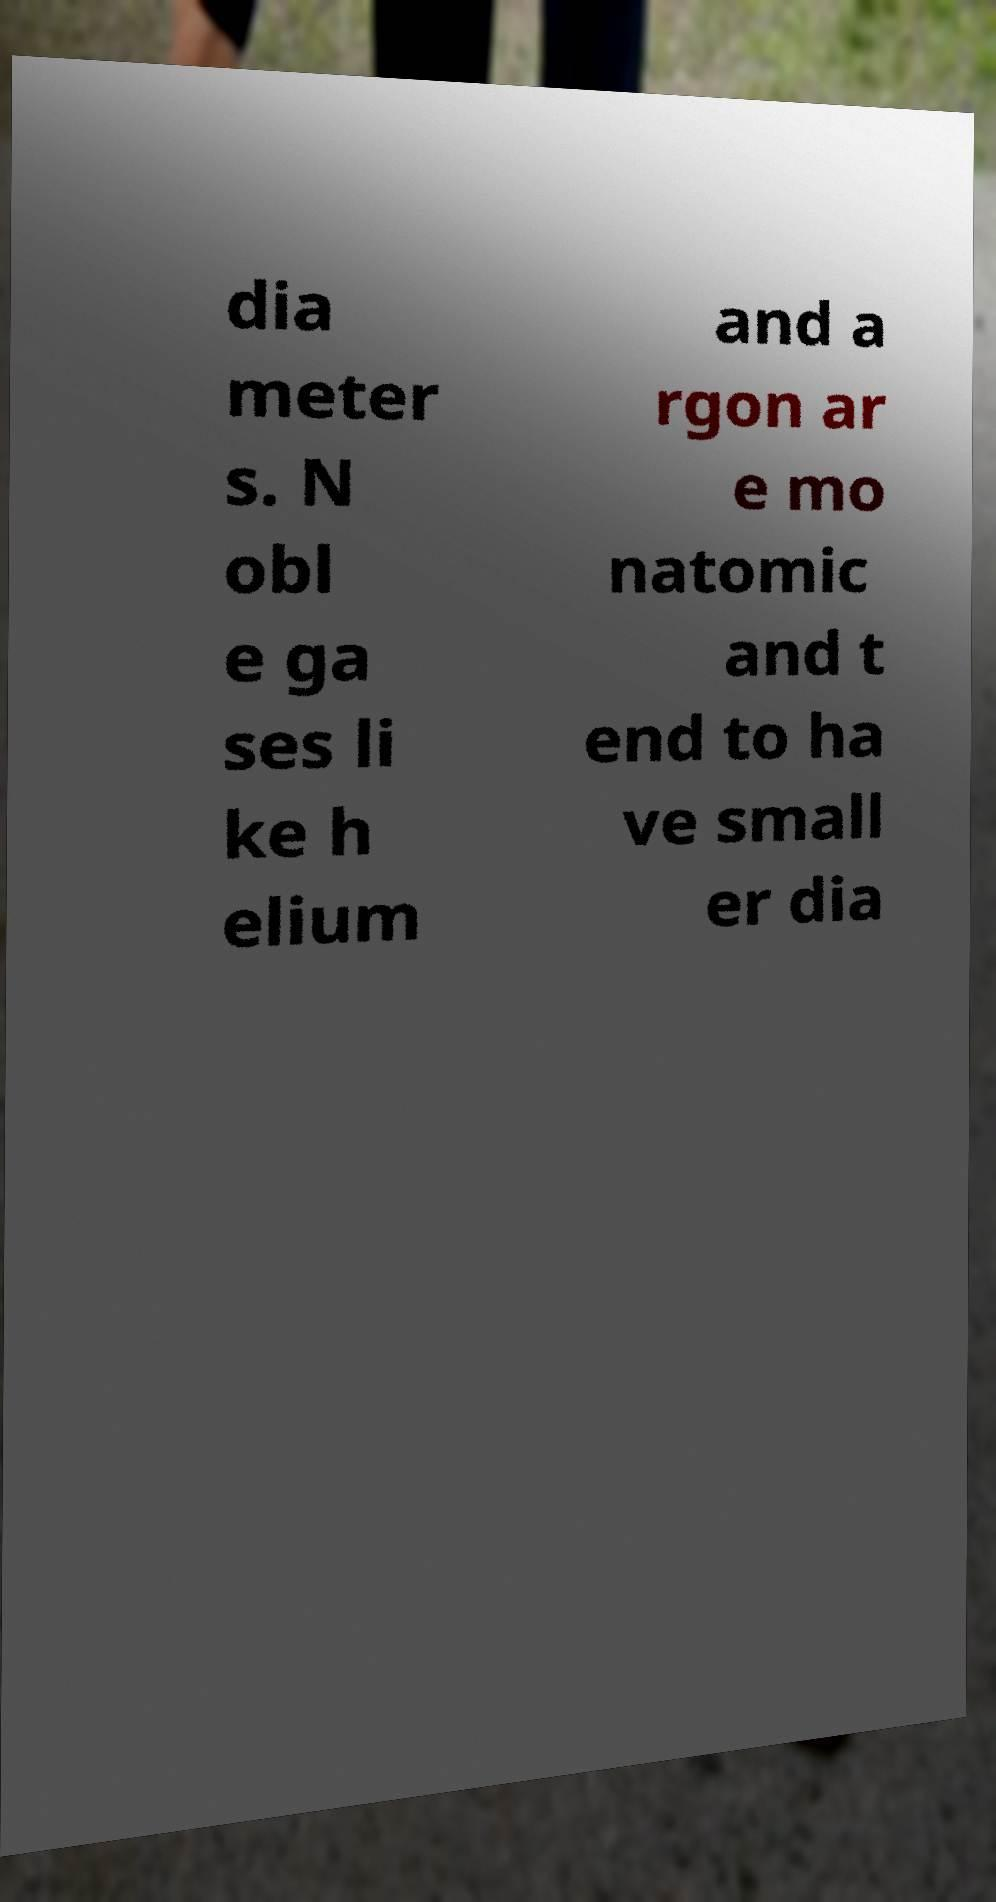Could you assist in decoding the text presented in this image and type it out clearly? dia meter s. N obl e ga ses li ke h elium and a rgon ar e mo natomic and t end to ha ve small er dia 